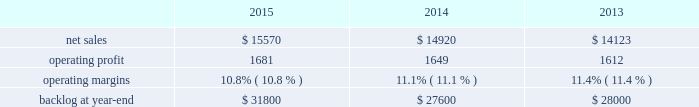Aeronautics our aeronautics business segment is engaged in the research , design , development , manufacture , integration , sustainment , support and upgrade of advanced military aircraft , including combat and air mobility aircraft , unmanned air vehicles and related technologies .
Aeronautics 2019 major programs include the f-35 lightning ii joint strike fighter , c-130 hercules , f-16 fighting falcon , c-5m super galaxy and f-22 raptor .
Aeronautics 2019 operating results included the following ( in millions ) : .
2015 compared to 2014 aeronautics 2019 net sales in 2015 increased $ 650 million , or 4% ( 4 % ) , compared to 2014 .
The increase was attributable to higher net sales of approximately $ 1.4 billion for f-35 production contracts due to increased volume on aircraft production and sustainment activities ; and approximately $ 150 million for the c-5 program due to increased deliveries ( nine aircraft delivered in 2015 compared to seven delivered in 2014 ) .
The increases were partially offset by lower net sales of approximately $ 350 million for the c-130 program due to fewer aircraft deliveries ( 21 aircraft delivered in 2015 , compared to 24 delivered in 2014 ) , lower sustainment activities and aircraft contract mix ; approximately $ 200 million due to decreased volume and lower risk retirements on various programs ; approximately $ 195 million for the f-16 program due to fewer deliveries ( 11 aircraft delivered in 2015 , compared to 17 delivered in 2014 ) ; and approximately $ 190 million for the f-22 program as a result of decreased sustainment activities .
Aeronautics 2019 operating profit in 2015 increased $ 32 million , or 2% ( 2 % ) , compared to 2014 .
Operating profit increased by approximately $ 240 million for f-35 production contracts due to increased volume and risk retirements ; and approximately $ 40 million for the c-5 program due to increased risk retirements .
These increases were offset by lower operating profit of approximately $ 90 million for the f-22 program due to lower risk retirements ; approximately $ 70 million for the c-130 program as a result of the reasons stated above for lower net sales ; and approximately $ 80 million due to decreased volume and risk retirements on various programs .
Adjustments not related to volume , including net profit booking rate adjustments and other matters , were approximately $ 100 million higher in 2015 compared to 2014 .
2014 compared to 2013 aeronautics 2019 net sales increased $ 797 million , or 6% ( 6 % ) , in 2014 as compared to 2013 .
The increase was primarily attributable to higher net sales of approximately $ 790 million for f-35 production contracts due to increased volume and sustainment activities ; about $ 55 million for the f-16 program due to increased deliveries ( 17 aircraft delivered in 2014 compared to 13 delivered in 2013 ) partially offset by contract mix ; and approximately $ 45 million for the f-22 program due to increased risk retirements .
The increases were partially offset by lower net sales of approximately $ 55 million for the f-35 development contract due to decreased volume , partially offset by the absence in 2014 of the downward revision to the profit booking rate that occurred in 2013 ; and about $ 40 million for the c-130 program due to fewer deliveries ( 24 aircraft delivered in 2014 compared to 25 delivered in 2013 ) and decreased sustainment activities , partially offset by contract mix .
Aeronautics 2019 operating profit increased $ 37 million , or 2% ( 2 % ) , in 2014 as compared to 2013 .
The increase was primarily attributable to higher operating profit of approximately $ 85 million for the f-35 development contract due to the absence in 2014 of the downward revision to the profit booking rate that occurred in 2013 ; about $ 75 million for the f-22 program due to increased risk retirements ; approximately $ 50 million for the c-130 program due to increased risk retirements and contract mix , partially offset by fewer deliveries ; and about $ 25 million for the c-5 program due to the absence in 2014 of the downward revisions to the profit booking rate that occurred in 2013 .
The increases were partially offset by lower operating profit of approximately $ 130 million for the f-16 program due to decreased risk retirements , partially offset by increased deliveries ; and about $ 70 million for sustainment activities due to decreased risk retirements and volume .
Operating profit was comparable for f-35 production contracts as higher volume was offset by lower risk retirements .
Adjustments not related to volume , including net profit booking rate adjustments and other matters , were approximately $ 105 million lower for 2014 compared to 2013. .
What was the ratio of the increase net sales to the increased volume of sales for the f-35 production contracts in 2015\\n\\n? 
Computations: (650 / 1.4)
Answer: 464.28571. 